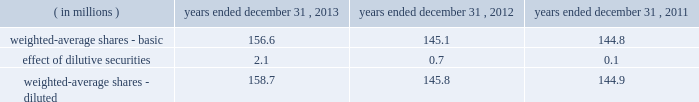Cdw corporation and subsidiaries notes to consolidated financial statements 2013 denominator was impacted by the common shares issued during both the ipo and the underwriters 2019 exercise in full of the overallotment option granted to them in connection with the ipo .
Because such common shares were issued on july 2 , 2013 and july 31 , 2013 , respectively , they are only partially reflected in the 2013 denominator .
Such shares will be fully reflected in the 2014 denominator .
See note 9 for additional discussion of the ipo .
The dilutive effect of outstanding restricted stock , restricted stock units , stock options and mpk plan units is reflected in the denominator for diluted earnings per share using the treasury stock method .
The following is a reconciliation of basic shares to diluted shares: .
For the years ended december 31 , 2013 , 2012 and 2011 , diluted earnings per share excludes the impact of 0.0 million , 0.0 million , and 4.3 million potential common shares , respectively , as their inclusion would have had an anti-dilutive effect .
12 .
Deferred compensation plan on march 10 , 2010 , in connection with the company 2019s purchase of $ 28.5 million principal amount of its outstanding senior subordinated debt , the company established the restricted debt unit plan ( the 201crdu plan 201d ) , an unfunded nonqualified deferred compensation plan .
The total number of rdus that can be granted under the rdu plan is 28500 .
At december 31 , 2013 , 28500 rdus were outstanding .
Rdus that are outstanding vest daily on a pro rata basis over the three-year period from january 1 , 2012 ( or , if later , the date of hire or the date of a subsequent rdu grant ) through december 31 , 2014 .
Participants have no rights to the underlying debt .
The total amount of compensation available to be paid under the rdu plan was initially to be based on two components , a principal component and an interest component .
The principal component credits the rdu plan with a notional amount equal to the $ 28.5 million face value of the senior subordinated notes ( the 201cdebt pool 201d ) , together with certain redemption premium equivalents as noted below .
The interest component credits the rdu plan with amounts equal to the interest that would have been earned on the debt pool from march 10 , 2010 through maturity on october 12 , 2017 , except as discussed below .
Interest amounts for 2010 and 2011 were deferred until 2012 , and thereafter , interest amounts were paid to participants semi-annually on the interest payment due dates .
Payments totaling $ 1.7 million and $ 1.3 million were made to participants under the rdu plan in april and october 2013 , respectively , in connection with the semi-annual interest payments due .
The company used a portion of the ipo proceeds together with incremental borrowings to redeem $ 324.0 million of the total senior subordinated notes outstanding on august 1 , 2013 .
In connection with the ipo and the partial redemption of the senior subordinated notes , the company amended the rdu plan to increase the retentive value of the plan .
In accordance with the original terms of the rdu plan , the principal component of the rdus converted to a cash-denominated pool upon the redemption of the senior subordinated notes .
In addition , the company added $ 1.4 million to the principal component in the year ended december 31 , 2013 as redemption premium equivalents in accordance with the terms of the rdu plan .
Under the terms of the amended rdu plan , upon the partial redemption of outstanding senior subordinated notes , the rdus ceased to accrue the proportionate related interest component credits .
The .
What was the average effect , in millions , of the dilutive securities in 2012-14? 
Computations: (((2.1 + 0.7) + 0.1) / 3)
Answer: 0.96667. Cdw corporation and subsidiaries notes to consolidated financial statements 2013 denominator was impacted by the common shares issued during both the ipo and the underwriters 2019 exercise in full of the overallotment option granted to them in connection with the ipo .
Because such common shares were issued on july 2 , 2013 and july 31 , 2013 , respectively , they are only partially reflected in the 2013 denominator .
Such shares will be fully reflected in the 2014 denominator .
See note 9 for additional discussion of the ipo .
The dilutive effect of outstanding restricted stock , restricted stock units , stock options and mpk plan units is reflected in the denominator for diluted earnings per share using the treasury stock method .
The following is a reconciliation of basic shares to diluted shares: .
For the years ended december 31 , 2013 , 2012 and 2011 , diluted earnings per share excludes the impact of 0.0 million , 0.0 million , and 4.3 million potential common shares , respectively , as their inclusion would have had an anti-dilutive effect .
12 .
Deferred compensation plan on march 10 , 2010 , in connection with the company 2019s purchase of $ 28.5 million principal amount of its outstanding senior subordinated debt , the company established the restricted debt unit plan ( the 201crdu plan 201d ) , an unfunded nonqualified deferred compensation plan .
The total number of rdus that can be granted under the rdu plan is 28500 .
At december 31 , 2013 , 28500 rdus were outstanding .
Rdus that are outstanding vest daily on a pro rata basis over the three-year period from january 1 , 2012 ( or , if later , the date of hire or the date of a subsequent rdu grant ) through december 31 , 2014 .
Participants have no rights to the underlying debt .
The total amount of compensation available to be paid under the rdu plan was initially to be based on two components , a principal component and an interest component .
The principal component credits the rdu plan with a notional amount equal to the $ 28.5 million face value of the senior subordinated notes ( the 201cdebt pool 201d ) , together with certain redemption premium equivalents as noted below .
The interest component credits the rdu plan with amounts equal to the interest that would have been earned on the debt pool from march 10 , 2010 through maturity on october 12 , 2017 , except as discussed below .
Interest amounts for 2010 and 2011 were deferred until 2012 , and thereafter , interest amounts were paid to participants semi-annually on the interest payment due dates .
Payments totaling $ 1.7 million and $ 1.3 million were made to participants under the rdu plan in april and october 2013 , respectively , in connection with the semi-annual interest payments due .
The company used a portion of the ipo proceeds together with incremental borrowings to redeem $ 324.0 million of the total senior subordinated notes outstanding on august 1 , 2013 .
In connection with the ipo and the partial redemption of the senior subordinated notes , the company amended the rdu plan to increase the retentive value of the plan .
In accordance with the original terms of the rdu plan , the principal component of the rdus converted to a cash-denominated pool upon the redemption of the senior subordinated notes .
In addition , the company added $ 1.4 million to the principal component in the year ended december 31 , 2013 as redemption premium equivalents in accordance with the terms of the rdu plan .
Under the terms of the amended rdu plan , upon the partial redemption of outstanding senior subordinated notes , the rdus ceased to accrue the proportionate related interest component credits .
The .
Under the rdu program in 2013 , what was the average of the two semi-annual interest payments , in millions? 
Computations: ((1.7 + 1.3) / 2)
Answer: 1.5. Cdw corporation and subsidiaries notes to consolidated financial statements 2013 denominator was impacted by the common shares issued during both the ipo and the underwriters 2019 exercise in full of the overallotment option granted to them in connection with the ipo .
Because such common shares were issued on july 2 , 2013 and july 31 , 2013 , respectively , they are only partially reflected in the 2013 denominator .
Such shares will be fully reflected in the 2014 denominator .
See note 9 for additional discussion of the ipo .
The dilutive effect of outstanding restricted stock , restricted stock units , stock options and mpk plan units is reflected in the denominator for diluted earnings per share using the treasury stock method .
The following is a reconciliation of basic shares to diluted shares: .
For the years ended december 31 , 2013 , 2012 and 2011 , diluted earnings per share excludes the impact of 0.0 million , 0.0 million , and 4.3 million potential common shares , respectively , as their inclusion would have had an anti-dilutive effect .
12 .
Deferred compensation plan on march 10 , 2010 , in connection with the company 2019s purchase of $ 28.5 million principal amount of its outstanding senior subordinated debt , the company established the restricted debt unit plan ( the 201crdu plan 201d ) , an unfunded nonqualified deferred compensation plan .
The total number of rdus that can be granted under the rdu plan is 28500 .
At december 31 , 2013 , 28500 rdus were outstanding .
Rdus that are outstanding vest daily on a pro rata basis over the three-year period from january 1 , 2012 ( or , if later , the date of hire or the date of a subsequent rdu grant ) through december 31 , 2014 .
Participants have no rights to the underlying debt .
The total amount of compensation available to be paid under the rdu plan was initially to be based on two components , a principal component and an interest component .
The principal component credits the rdu plan with a notional amount equal to the $ 28.5 million face value of the senior subordinated notes ( the 201cdebt pool 201d ) , together with certain redemption premium equivalents as noted below .
The interest component credits the rdu plan with amounts equal to the interest that would have been earned on the debt pool from march 10 , 2010 through maturity on october 12 , 2017 , except as discussed below .
Interest amounts for 2010 and 2011 were deferred until 2012 , and thereafter , interest amounts were paid to participants semi-annually on the interest payment due dates .
Payments totaling $ 1.7 million and $ 1.3 million were made to participants under the rdu plan in april and october 2013 , respectively , in connection with the semi-annual interest payments due .
The company used a portion of the ipo proceeds together with incremental borrowings to redeem $ 324.0 million of the total senior subordinated notes outstanding on august 1 , 2013 .
In connection with the ipo and the partial redemption of the senior subordinated notes , the company amended the rdu plan to increase the retentive value of the plan .
In accordance with the original terms of the rdu plan , the principal component of the rdus converted to a cash-denominated pool upon the redemption of the senior subordinated notes .
In addition , the company added $ 1.4 million to the principal component in the year ended december 31 , 2013 as redemption premium equivalents in accordance with the terms of the rdu plan .
Under the terms of the amended rdu plan , upon the partial redemption of outstanding senior subordinated notes , the rdus ceased to accrue the proportionate related interest component credits .
The .
For the year ended december 31 , 2011 , diluted earnings per share excludes the impact of 4.3 million potential common shares as their inclusion would have had an anti-dilutive effect . what would the weighted-average shares be if these shares were not excluded? 
Computations: (144.9 + 4.3)
Answer: 149.2. 